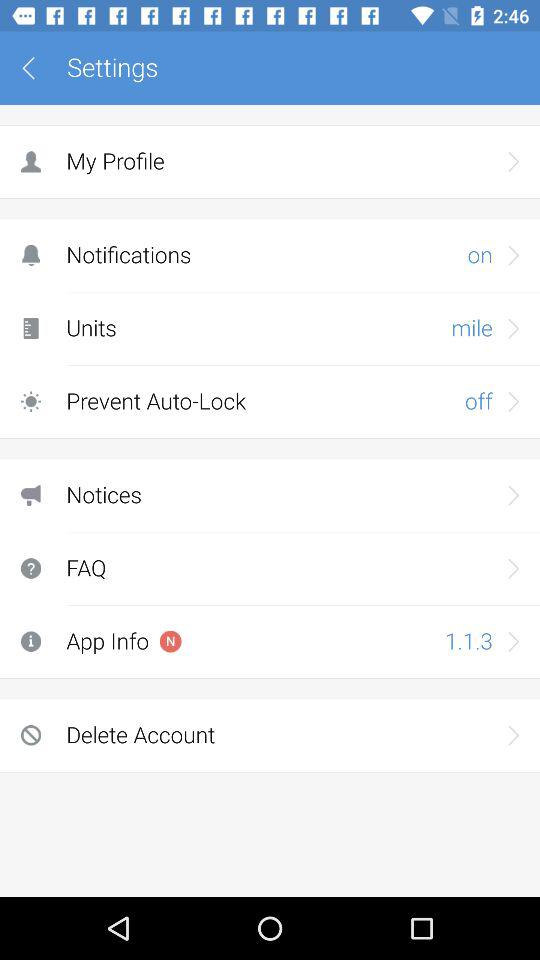Which questions are the most frequently asked?
When the provided information is insufficient, respond with <no answer>. <no answer> 